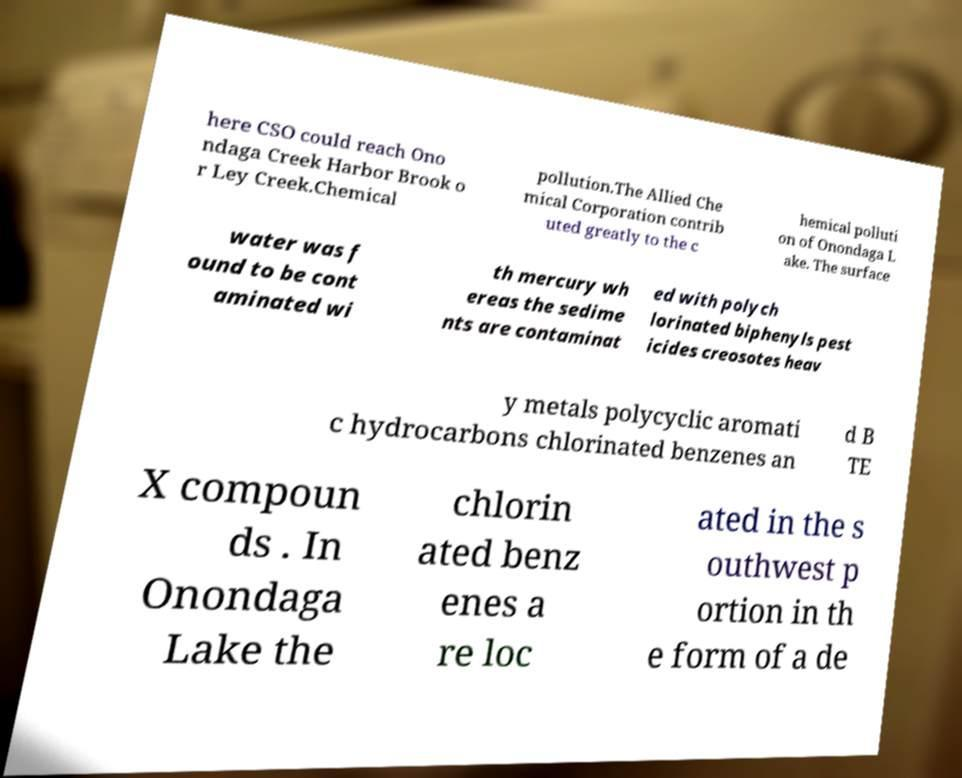Can you accurately transcribe the text from the provided image for me? here CSO could reach Ono ndaga Creek Harbor Brook o r Ley Creek.Chemical pollution.The Allied Che mical Corporation contrib uted greatly to the c hemical polluti on of Onondaga L ake. The surface water was f ound to be cont aminated wi th mercury wh ereas the sedime nts are contaminat ed with polych lorinated biphenyls pest icides creosotes heav y metals polycyclic aromati c hydrocarbons chlorinated benzenes an d B TE X compoun ds . In Onondaga Lake the chlorin ated benz enes a re loc ated in the s outhwest p ortion in th e form of a de 